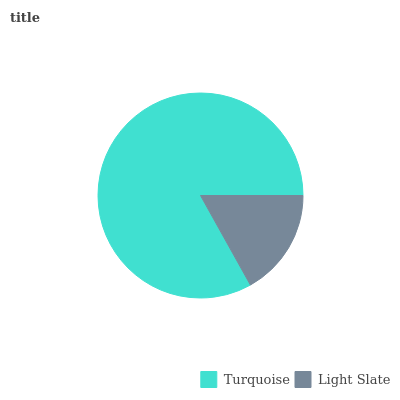Is Light Slate the minimum?
Answer yes or no. Yes. Is Turquoise the maximum?
Answer yes or no. Yes. Is Light Slate the maximum?
Answer yes or no. No. Is Turquoise greater than Light Slate?
Answer yes or no. Yes. Is Light Slate less than Turquoise?
Answer yes or no. Yes. Is Light Slate greater than Turquoise?
Answer yes or no. No. Is Turquoise less than Light Slate?
Answer yes or no. No. Is Turquoise the high median?
Answer yes or no. Yes. Is Light Slate the low median?
Answer yes or no. Yes. Is Light Slate the high median?
Answer yes or no. No. Is Turquoise the low median?
Answer yes or no. No. 